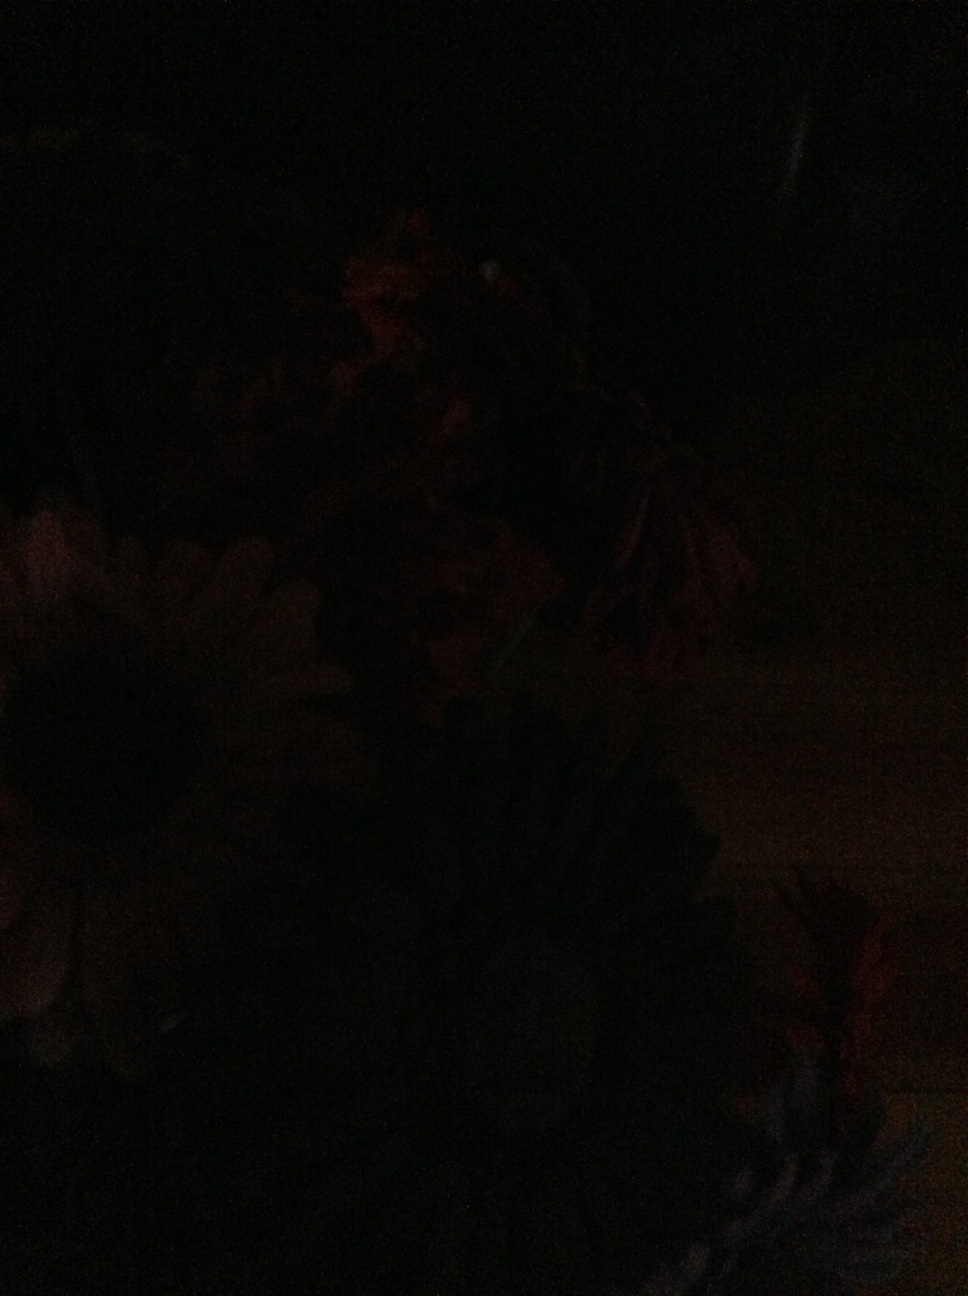Can you identify any shapes or figures in this image? The image is primarily dark, yet it seems there are some discernable shapes that resemble the outlines of flowers. However, without adequate lighting, it's difficult to identify any specific figures or details. Imagine if there were mythical creatures hidden in the darkness of this image. What could they be? In the depths of this shadowy image, one could imagine an array of mythical creatures lurking. Perhaps tiny moonlit fairies flutter among the flowers, invisible to the naked eye. There could be shadowy sylphs darting between petals, whispering ancient secrets to the blooms. And maybe, just maybe, a nocturnal guardian spirit watches over the garden, silently ensuring the peace and magic of the night remains undisturbed. Could this image be a metaphor for something in real life? This image could serve as a metaphor for moments in life that are obscured by uncertainty or darkness. It reminds us that even when things seem unclear or hidden, there are underlying elements and potential waiting to be discovered. Just as the flowers are present in the dark but not fully visible, so too can our strengths and opportunities be masked by our current circumstances, waiting for the right light to reveal them. Create a very imaginative scenario based on this image. Imagine this image is a glimpse into a hidden realm where night-blooming flowers guard a portal to dreams. Each flower opens only under the canopy of stars, revealing petals that shimmer with the dreams of every creature that has ever slept. The garden keeper, an ancient being made of stardust and moonlight, tends to the flowers, ensuring they flourish in the darkness. Every night, she waters them with the essence of the Milky Way, as shooting stars fall gently like rain. Travelers who find this secret garden are gifted with the most wondrous dreams, transported to lands where their deepest desires and wildest fantasies come to life, if only for the span of a single night. 